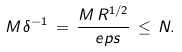<formula> <loc_0><loc_0><loc_500><loc_500>M \, \delta ^ { - 1 } \, = \, \frac { M \, R ^ { 1 / 2 } } { \ e p s } \, \leq \, N .</formula> 